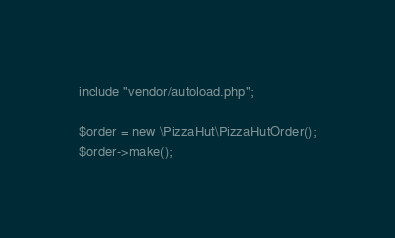<code> <loc_0><loc_0><loc_500><loc_500><_PHP_>
include "vendor/autoload.php";

$order = new \PizzaHut\PizzaHutOrder();
$order->make();
</code> 